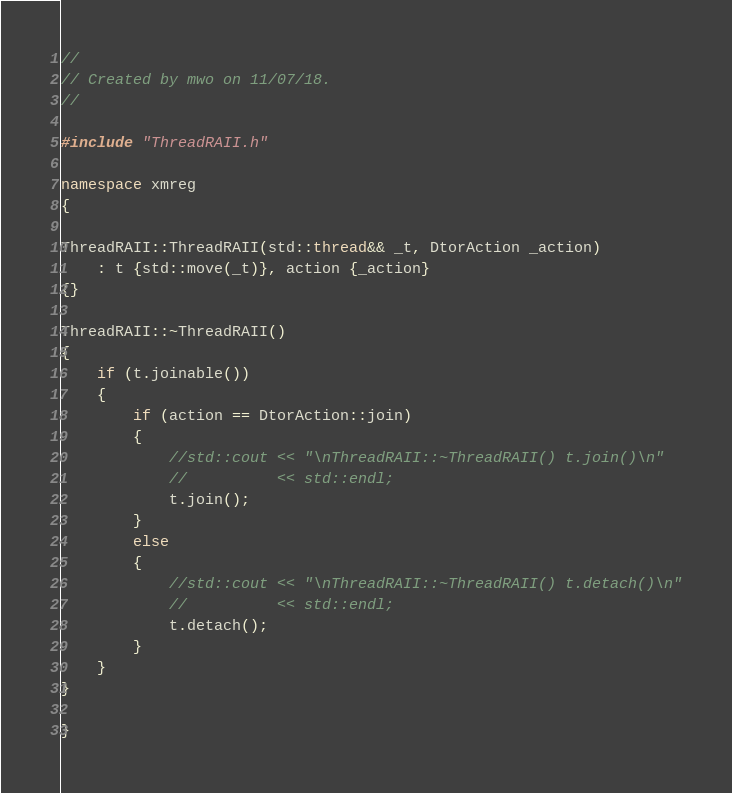Convert code to text. <code><loc_0><loc_0><loc_500><loc_500><_C++_>//
// Created by mwo on 11/07/18.
//

#include "ThreadRAII.h"

namespace xmreg
{

ThreadRAII::ThreadRAII(std::thread&& _t, DtorAction _action)
    : t {std::move(_t)}, action {_action}
{}

ThreadRAII::~ThreadRAII()
{
    if (t.joinable())
    {
        if (action == DtorAction::join)
        {
            //std::cout << "\nThreadRAII::~ThreadRAII() t.join()\n"
            //          << std::endl;
            t.join();
        }
        else
        {
            //std::cout << "\nThreadRAII::~ThreadRAII() t.detach()\n"
            //          << std::endl;
            t.detach();            
        }
    }
}

}
</code> 